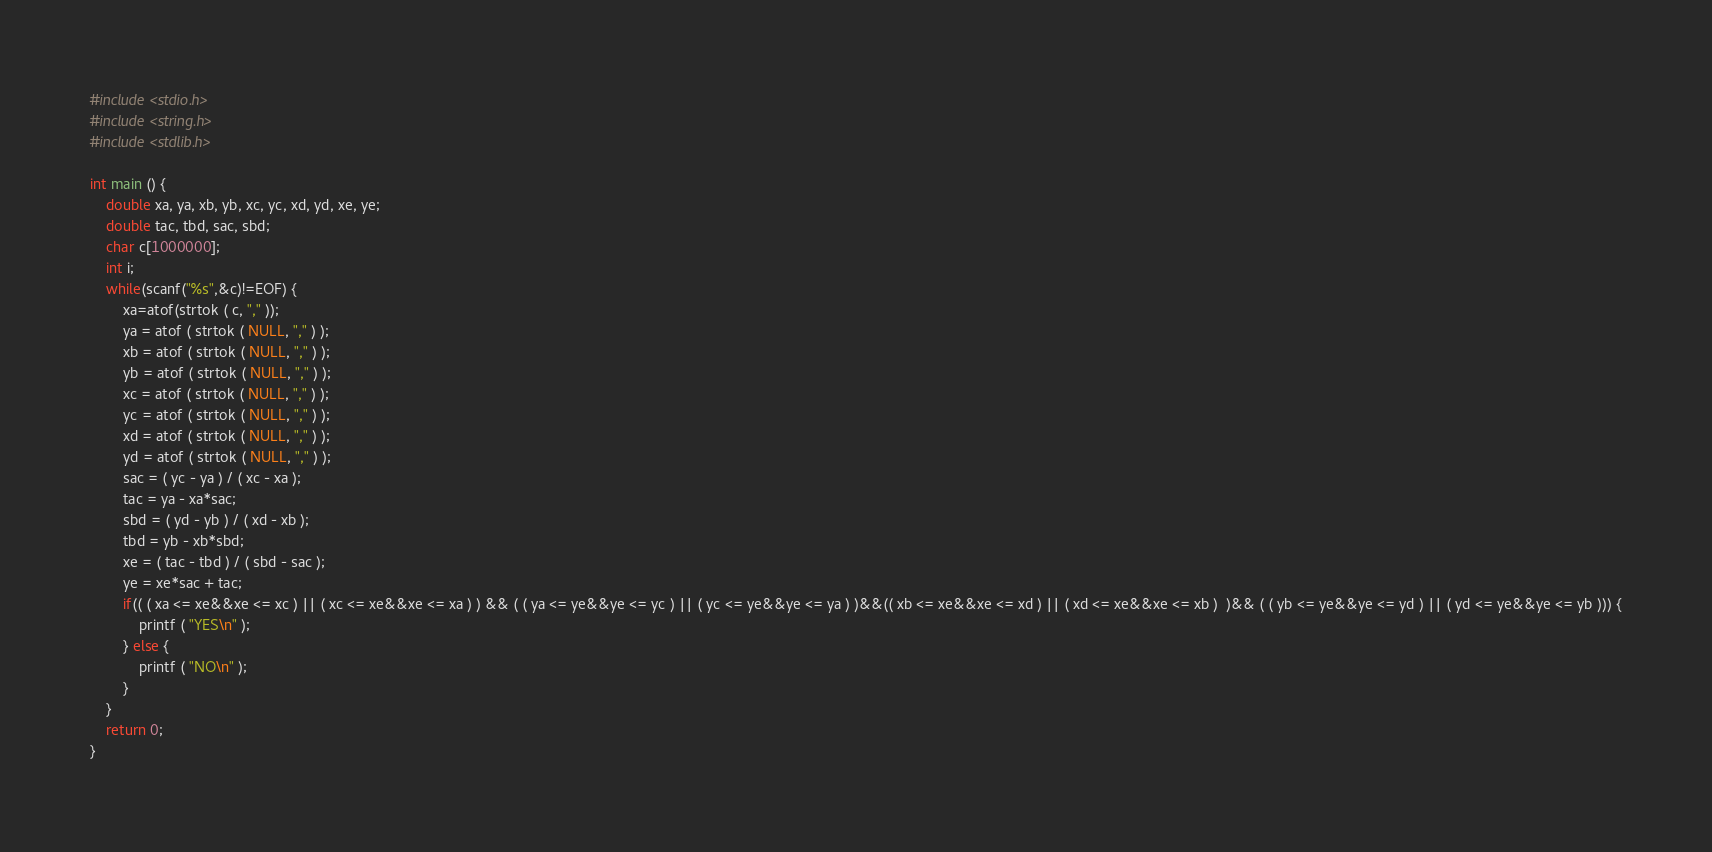<code> <loc_0><loc_0><loc_500><loc_500><_C_>#include <stdio.h>
#include <string.h>
#include <stdlib.h>

int main () {
	double xa, ya, xb, yb, xc, yc, xd, yd, xe, ye;
	double tac, tbd, sac, sbd;
	char c[1000000];
	int i;
	while(scanf("%s",&c)!=EOF) {
		xa=atof(strtok ( c, "," ));
		ya = atof ( strtok ( NULL, "," ) ); 
		xb = atof ( strtok ( NULL, "," ) ); 
		yb = atof ( strtok ( NULL, "," ) ); 
		xc = atof ( strtok ( NULL, "," ) ); 
		yc = atof ( strtok ( NULL, "," ) ); 
		xd = atof ( strtok ( NULL, "," ) ); 
		yd = atof ( strtok ( NULL, "," ) ); 
		sac = ( yc - ya ) / ( xc - xa );
		tac = ya - xa*sac;
		sbd = ( yd - yb ) / ( xd - xb );
		tbd = yb - xb*sbd;
		xe = ( tac - tbd ) / ( sbd - sac );
		ye = xe*sac + tac;
		if(( ( xa <= xe&&xe <= xc ) || ( xc <= xe&&xe <= xa ) ) && ( ( ya <= ye&&ye <= yc ) || ( yc <= ye&&ye <= ya ) )&&(( xb <= xe&&xe <= xd ) || ( xd <= xe&&xe <= xb )  )&& ( ( yb <= ye&&ye <= yd ) || ( yd <= ye&&ye <= yb ))) {
			printf ( "YES\n" );
		} else {
			printf ( "NO\n" );
		}
	}
	return 0;
}</code> 